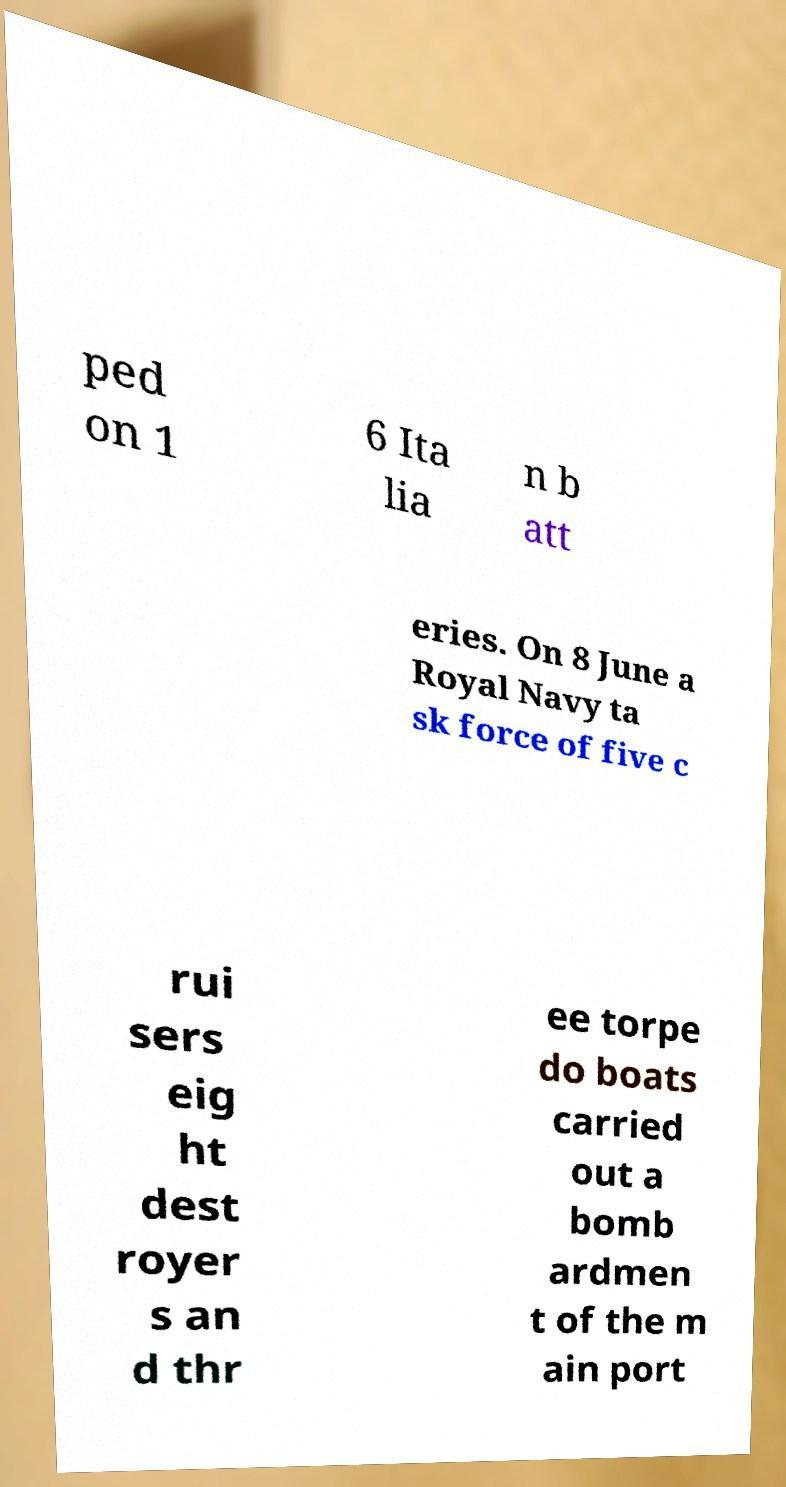For documentation purposes, I need the text within this image transcribed. Could you provide that? ped on 1 6 Ita lia n b att eries. On 8 June a Royal Navy ta sk force of five c rui sers eig ht dest royer s an d thr ee torpe do boats carried out a bomb ardmen t of the m ain port 